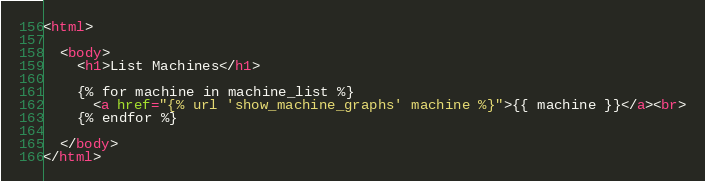Convert code to text. <code><loc_0><loc_0><loc_500><loc_500><_HTML_><html>

  <body>
    <h1>List Machines</h1>

    {% for machine in machine_list %}
      <a href="{% url 'show_machine_graphs' machine %}">{{ machine }}</a><br>
    {% endfor %}

  </body>
</html>
</code> 